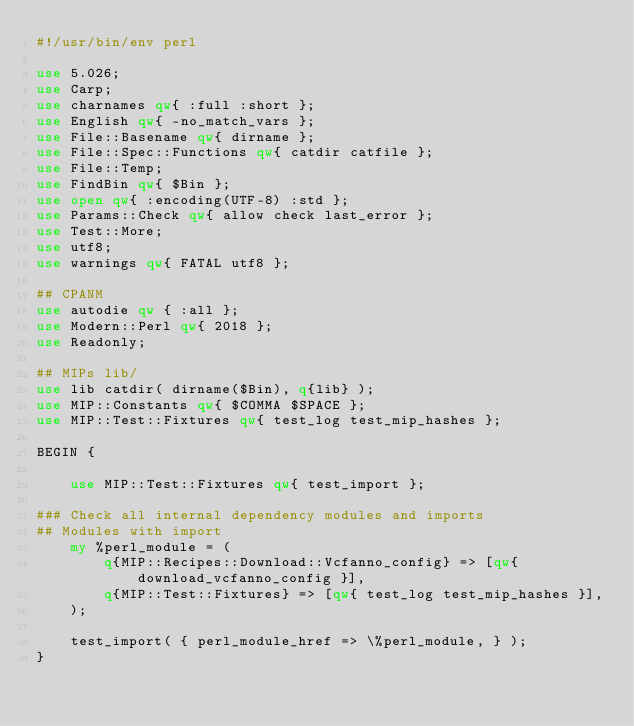<code> <loc_0><loc_0><loc_500><loc_500><_Perl_>#!/usr/bin/env perl

use 5.026;
use Carp;
use charnames qw{ :full :short };
use English qw{ -no_match_vars };
use File::Basename qw{ dirname };
use File::Spec::Functions qw{ catdir catfile };
use File::Temp;
use FindBin qw{ $Bin };
use open qw{ :encoding(UTF-8) :std };
use Params::Check qw{ allow check last_error };
use Test::More;
use utf8;
use warnings qw{ FATAL utf8 };

## CPANM
use autodie qw { :all };
use Modern::Perl qw{ 2018 };
use Readonly;

## MIPs lib/
use lib catdir( dirname($Bin), q{lib} );
use MIP::Constants qw{ $COMMA $SPACE };
use MIP::Test::Fixtures qw{ test_log test_mip_hashes };

BEGIN {

    use MIP::Test::Fixtures qw{ test_import };

### Check all internal dependency modules and imports
## Modules with import
    my %perl_module = (
        q{MIP::Recipes::Download::Vcfanno_config} => [qw{ download_vcfanno_config }],
        q{MIP::Test::Fixtures} => [qw{ test_log test_mip_hashes }],
    );

    test_import( { perl_module_href => \%perl_module, } );
}
</code> 